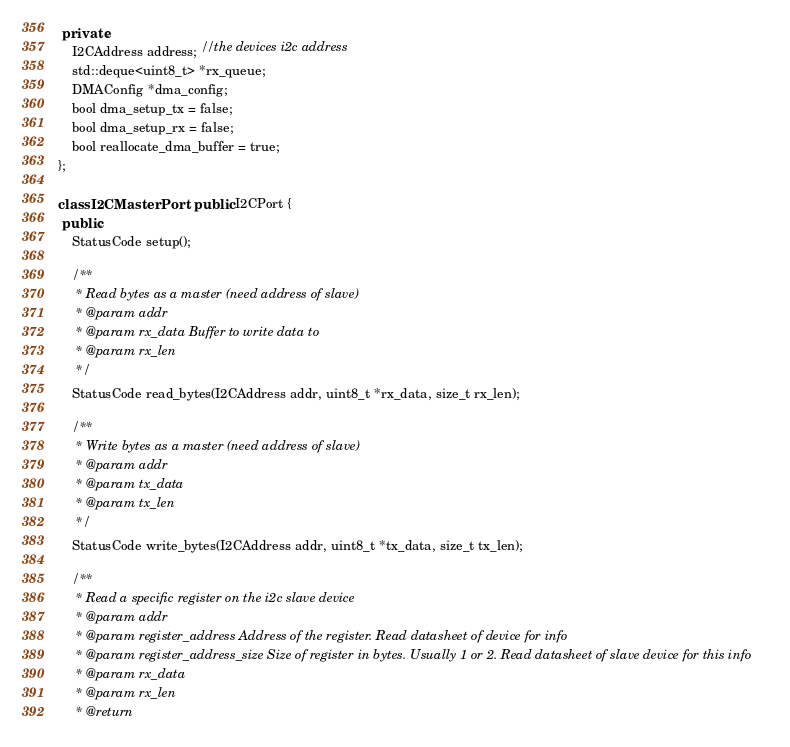<code> <loc_0><loc_0><loc_500><loc_500><_C++_>
 private:
	I2CAddress address; //the devices i2c address
	std::deque<uint8_t> *rx_queue;
	DMAConfig *dma_config;
	bool dma_setup_tx = false;
	bool dma_setup_rx = false;
	bool reallocate_dma_buffer = true;
};

class I2CMasterPort : public I2CPort {
 public:
	StatusCode setup();

	/**
	 * Read bytes as a master (need address of slave)
	 * @param addr
	 * @param rx_data Buffer to write data to
	 * @param rx_len
	 */
	StatusCode read_bytes(I2CAddress addr, uint8_t *rx_data, size_t rx_len);

	/**
	 * Write bytes as a master (need address of slave)
	 * @param addr
	 * @param tx_data
	 * @param tx_len
	 */
	StatusCode write_bytes(I2CAddress addr, uint8_t *tx_data, size_t tx_len);

	/**
	 * Read a specific register on the i2c slave device
	 * @param addr
	 * @param register_address Address of the register. Read datasheet of device for info
	 * @param register_address_size Size of register in bytes. Usually 1 or 2. Read datasheet of slave device for this info
	 * @param rx_data
	 * @param rx_len
	 * @return</code> 